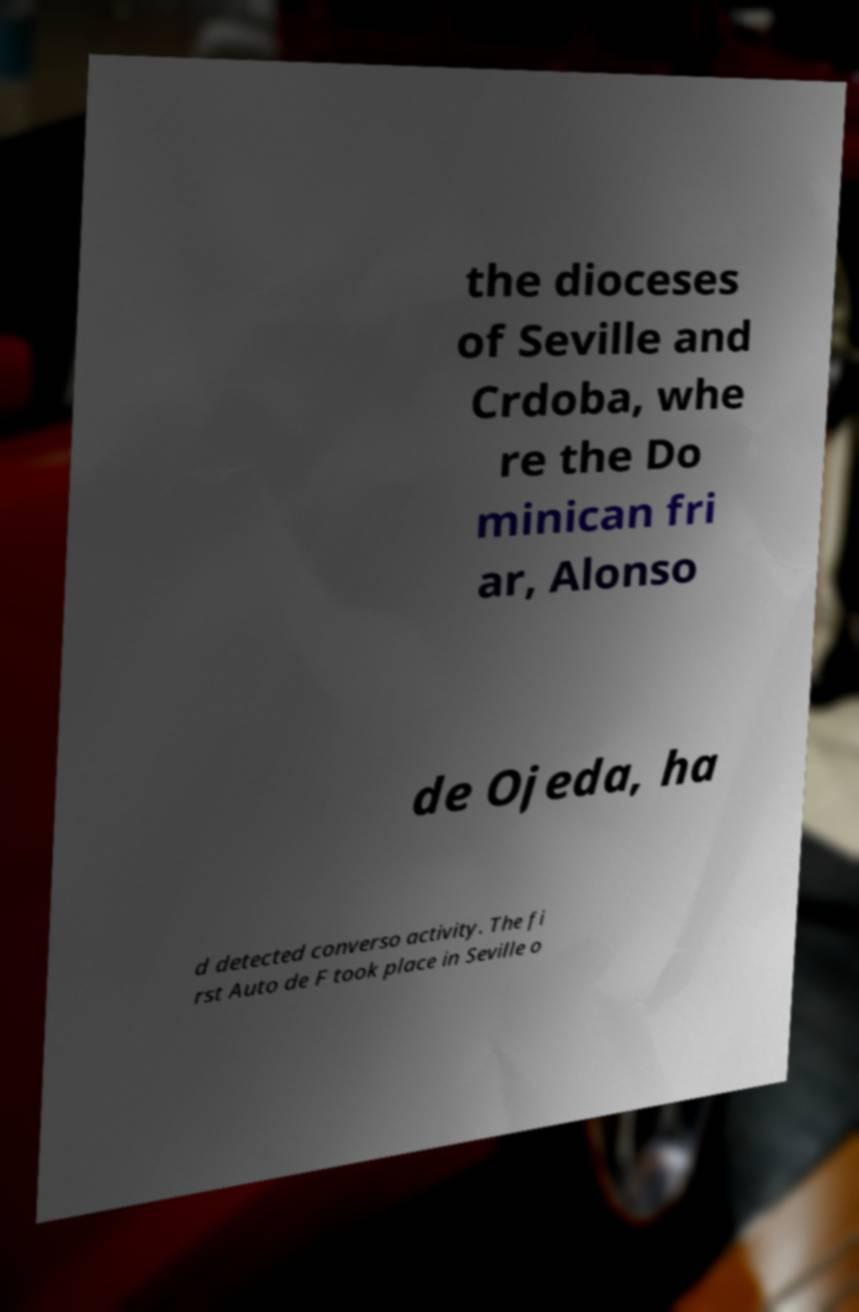I need the written content from this picture converted into text. Can you do that? the dioceses of Seville and Crdoba, whe re the Do minican fri ar, Alonso de Ojeda, ha d detected converso activity. The fi rst Auto de F took place in Seville o 